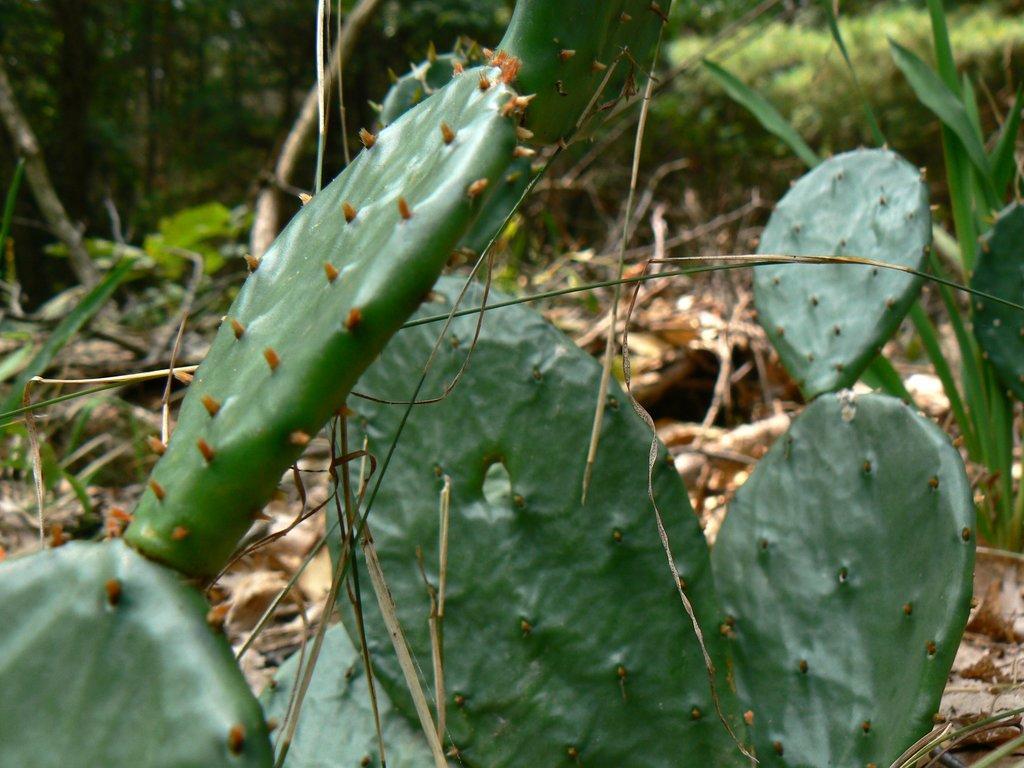Could you give a brief overview of what you see in this image? In this image there is a Cactus plant towards the bottom of the image, there are dried leaves and twigs on the ground, at the background of the image there are trees, there is a plant towards the right of the image. 